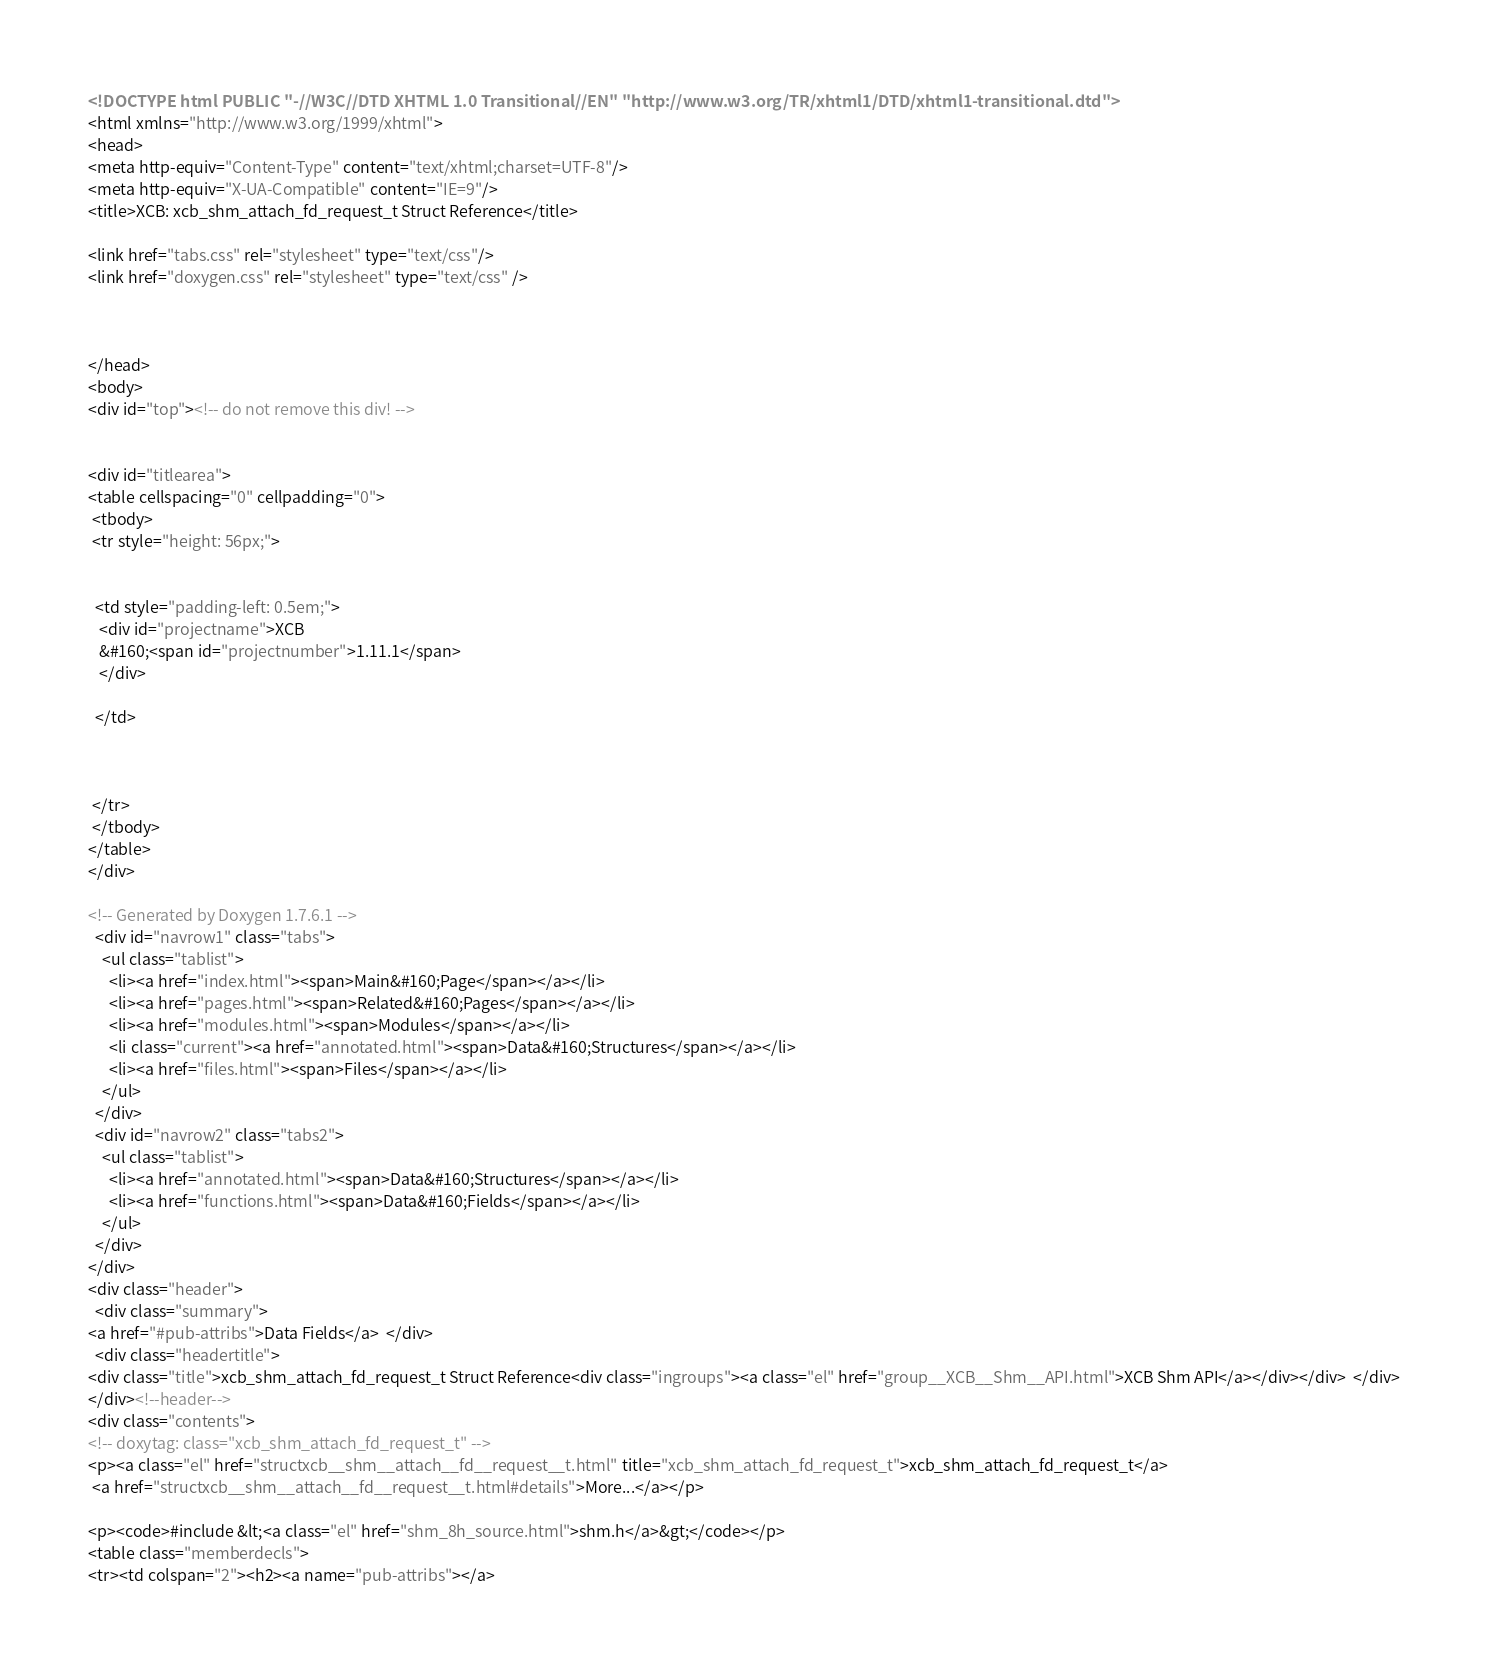<code> <loc_0><loc_0><loc_500><loc_500><_HTML_><!DOCTYPE html PUBLIC "-//W3C//DTD XHTML 1.0 Transitional//EN" "http://www.w3.org/TR/xhtml1/DTD/xhtml1-transitional.dtd">
<html xmlns="http://www.w3.org/1999/xhtml">
<head>
<meta http-equiv="Content-Type" content="text/xhtml;charset=UTF-8"/>
<meta http-equiv="X-UA-Compatible" content="IE=9"/>
<title>XCB: xcb_shm_attach_fd_request_t Struct Reference</title>

<link href="tabs.css" rel="stylesheet" type="text/css"/>
<link href="doxygen.css" rel="stylesheet" type="text/css" />



</head>
<body>
<div id="top"><!-- do not remove this div! -->


<div id="titlearea">
<table cellspacing="0" cellpadding="0">
 <tbody>
 <tr style="height: 56px;">
  
  
  <td style="padding-left: 0.5em;">
   <div id="projectname">XCB
   &#160;<span id="projectnumber">1.11.1</span>
   </div>
   
  </td>
  
  
  
 </tr>
 </tbody>
</table>
</div>

<!-- Generated by Doxygen 1.7.6.1 -->
  <div id="navrow1" class="tabs">
    <ul class="tablist">
      <li><a href="index.html"><span>Main&#160;Page</span></a></li>
      <li><a href="pages.html"><span>Related&#160;Pages</span></a></li>
      <li><a href="modules.html"><span>Modules</span></a></li>
      <li class="current"><a href="annotated.html"><span>Data&#160;Structures</span></a></li>
      <li><a href="files.html"><span>Files</span></a></li>
    </ul>
  </div>
  <div id="navrow2" class="tabs2">
    <ul class="tablist">
      <li><a href="annotated.html"><span>Data&#160;Structures</span></a></li>
      <li><a href="functions.html"><span>Data&#160;Fields</span></a></li>
    </ul>
  </div>
</div>
<div class="header">
  <div class="summary">
<a href="#pub-attribs">Data Fields</a>  </div>
  <div class="headertitle">
<div class="title">xcb_shm_attach_fd_request_t Struct Reference<div class="ingroups"><a class="el" href="group__XCB__Shm__API.html">XCB Shm API</a></div></div>  </div>
</div><!--header-->
<div class="contents">
<!-- doxytag: class="xcb_shm_attach_fd_request_t" -->
<p><a class="el" href="structxcb__shm__attach__fd__request__t.html" title="xcb_shm_attach_fd_request_t">xcb_shm_attach_fd_request_t</a>  
 <a href="structxcb__shm__attach__fd__request__t.html#details">More...</a></p>

<p><code>#include &lt;<a class="el" href="shm_8h_source.html">shm.h</a>&gt;</code></p>
<table class="memberdecls">
<tr><td colspan="2"><h2><a name="pub-attribs"></a></code> 